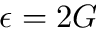<formula> <loc_0><loc_0><loc_500><loc_500>\epsilon = 2 G</formula> 